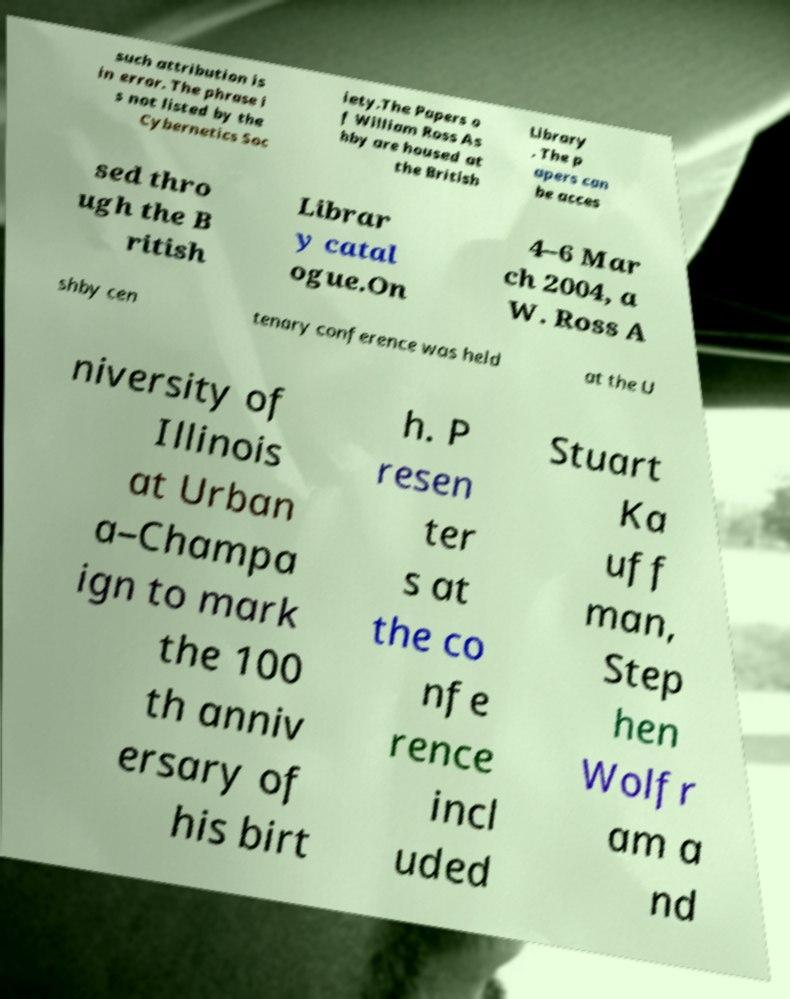Could you extract and type out the text from this image? such attribution is in error. The phrase i s not listed by the Cybernetics Soc iety.The Papers o f William Ross As hby are housed at the British Library . The p apers can be acces sed thro ugh the B ritish Librar y catal ogue.On 4–6 Mar ch 2004, a W. Ross A shby cen tenary conference was held at the U niversity of Illinois at Urban a–Champa ign to mark the 100 th anniv ersary of his birt h. P resen ter s at the co nfe rence incl uded Stuart Ka uff man, Step hen Wolfr am a nd 